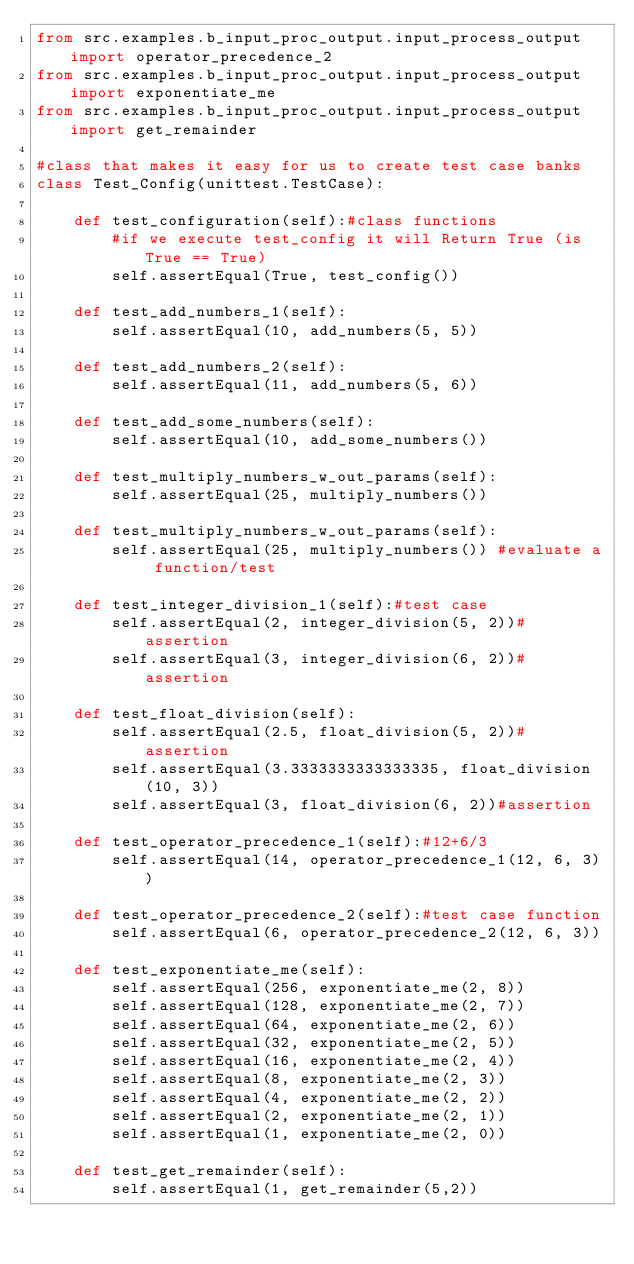Convert code to text. <code><loc_0><loc_0><loc_500><loc_500><_Python_>from src.examples.b_input_proc_output.input_process_output import operator_precedence_2
from src.examples.b_input_proc_output.input_process_output import exponentiate_me
from src.examples.b_input_proc_output.input_process_output import get_remainder

#class that makes it easy for us to create test case banks
class Test_Config(unittest.TestCase):

    def test_configuration(self):#class functions
        #if we execute test_config it will Return True (is True == True)
        self.assertEqual(True, test_config())

    def test_add_numbers_1(self):
        self.assertEqual(10, add_numbers(5, 5))

    def test_add_numbers_2(self):
        self.assertEqual(11, add_numbers(5, 6))

    def test_add_some_numbers(self):
        self.assertEqual(10, add_some_numbers())

    def test_multiply_numbers_w_out_params(self):
        self.assertEqual(25, multiply_numbers()) 

    def test_multiply_numbers_w_out_params(self):
        self.assertEqual(25, multiply_numbers()) #evaluate a function/test

    def test_integer_division_1(self):#test case
        self.assertEqual(2, integer_division(5, 2))#assertion
        self.assertEqual(3, integer_division(6, 2))#assertion

    def test_float_division(self):
        self.assertEqual(2.5, float_division(5, 2))#assertion
        self.assertEqual(3.3333333333333335, float_division(10, 3))
        self.assertEqual(3, float_division(6, 2))#assertion

    def test_operator_precedence_1(self):#12+6/3
        self.assertEqual(14, operator_precedence_1(12, 6, 3))

    def test_operator_precedence_2(self):#test case function
        self.assertEqual(6, operator_precedence_2(12, 6, 3))

    def test_exponentiate_me(self):
        self.assertEqual(256, exponentiate_me(2, 8))
        self.assertEqual(128, exponentiate_me(2, 7))
        self.assertEqual(64, exponentiate_me(2, 6))
        self.assertEqual(32, exponentiate_me(2, 5))
        self.assertEqual(16, exponentiate_me(2, 4))
        self.assertEqual(8, exponentiate_me(2, 3))
        self.assertEqual(4, exponentiate_me(2, 2))
        self.assertEqual(2, exponentiate_me(2, 1))
        self.assertEqual(1, exponentiate_me(2, 0))

    def test_get_remainder(self):
        self.assertEqual(1, get_remainder(5,2))
</code> 